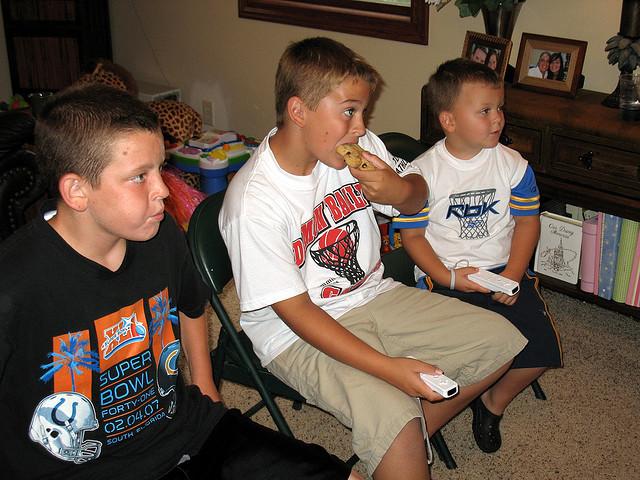Are the boys being lazy?
Be succinct. Yes. What game console are the boys using?
Concise answer only. Wii. Is there an umbrella in the background?
Quick response, please. No. What major sporting event is listed on black shirt?
Quick response, please. Super bowl. 